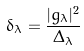<formula> <loc_0><loc_0><loc_500><loc_500>\delta _ { \lambda } = \frac { | g _ { \lambda } | ^ { 2 } } { \Delta _ { \lambda } }</formula> 